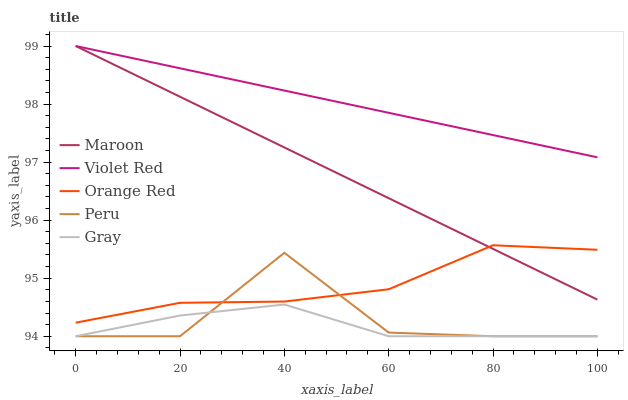Does Orange Red have the minimum area under the curve?
Answer yes or no. No. Does Orange Red have the maximum area under the curve?
Answer yes or no. No. Is Orange Red the smoothest?
Answer yes or no. No. Is Orange Red the roughest?
Answer yes or no. No. Does Orange Red have the lowest value?
Answer yes or no. No. Does Orange Red have the highest value?
Answer yes or no. No. Is Orange Red less than Violet Red?
Answer yes or no. Yes. Is Violet Red greater than Orange Red?
Answer yes or no. Yes. Does Orange Red intersect Violet Red?
Answer yes or no. No. 